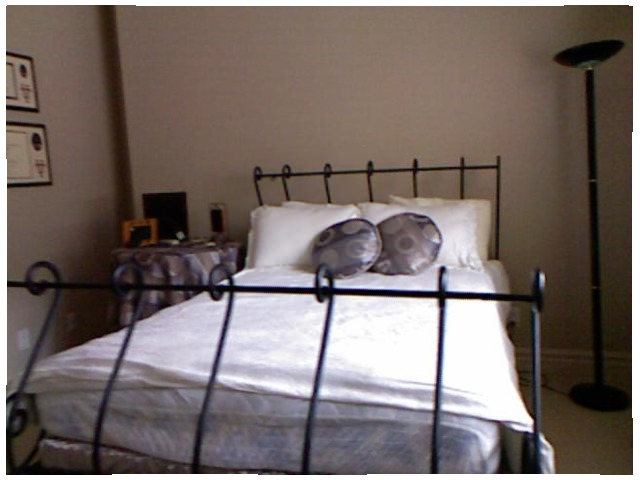<image>
Can you confirm if the picture frame is on the wall? No. The picture frame is not positioned on the wall. They may be near each other, but the picture frame is not supported by or resting on top of the wall. Is the bed behind the footboard? Yes. From this viewpoint, the bed is positioned behind the footboard, with the footboard partially or fully occluding the bed. Where is the pillow in relation to the pillow? Is it to the right of the pillow? No. The pillow is not to the right of the pillow. The horizontal positioning shows a different relationship. Is the bed under the picture? No. The bed is not positioned under the picture. The vertical relationship between these objects is different. 